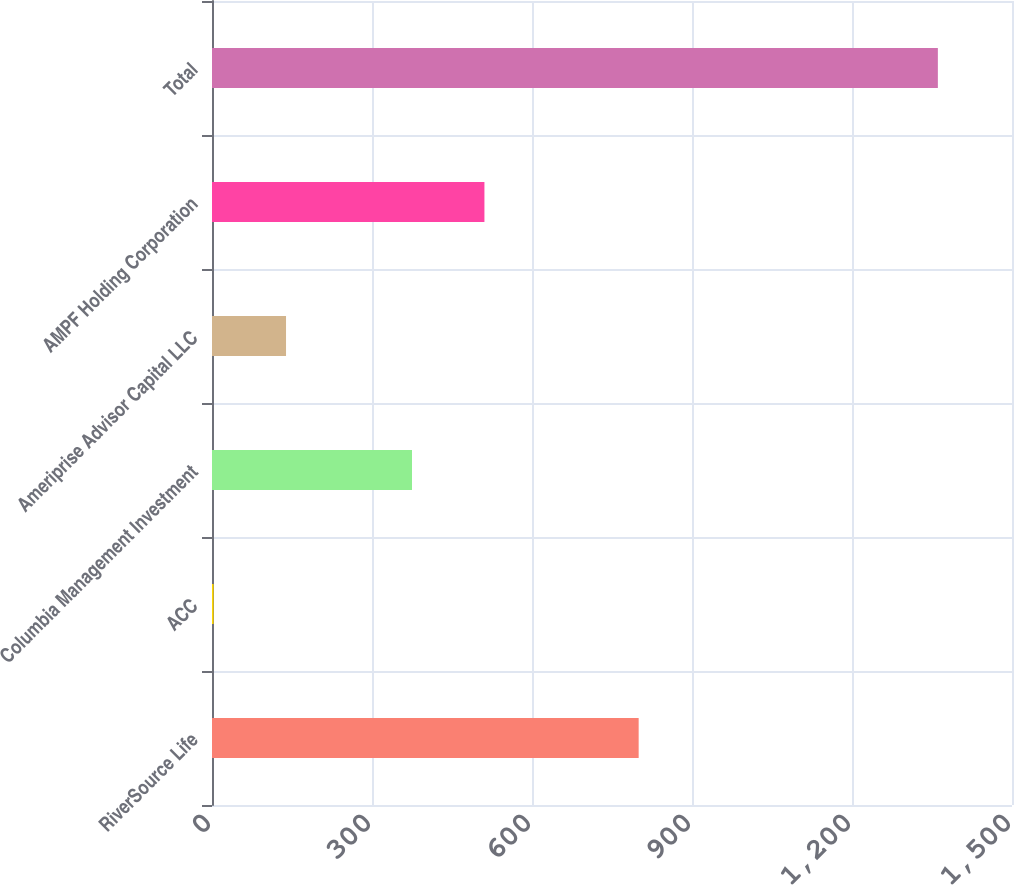Convert chart to OTSL. <chart><loc_0><loc_0><loc_500><loc_500><bar_chart><fcel>RiverSource Life<fcel>ACC<fcel>Columbia Management Investment<fcel>Ameriprise Advisor Capital LLC<fcel>AMPF Holding Corporation<fcel>Total<nl><fcel>800<fcel>3<fcel>375<fcel>138.8<fcel>510.8<fcel>1361<nl></chart> 